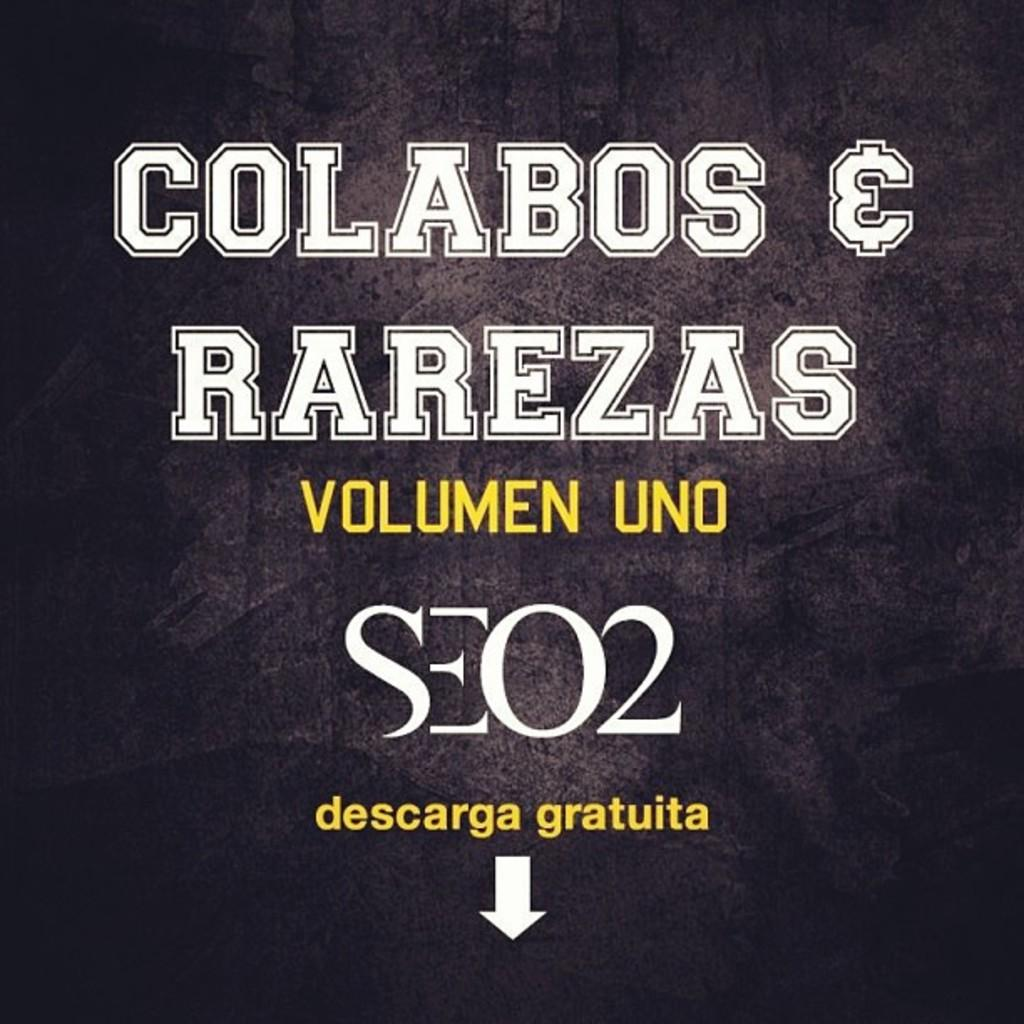<image>
Describe the image concisely. Poster that says "COlabos & Rarezas" with a black background. 